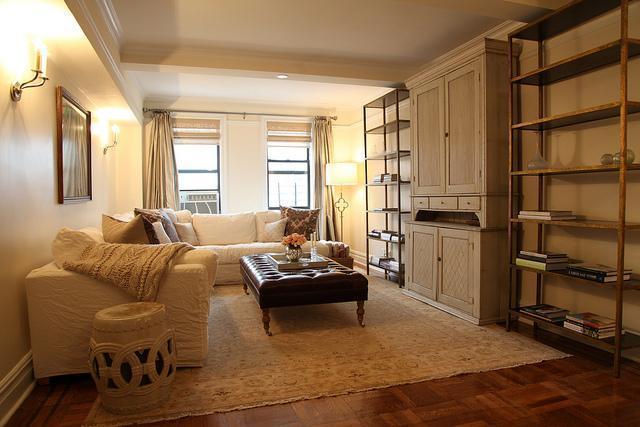How many shelves are visible?
Give a very brief answer. 14. How many couches are there?
Give a very brief answer. 2. 